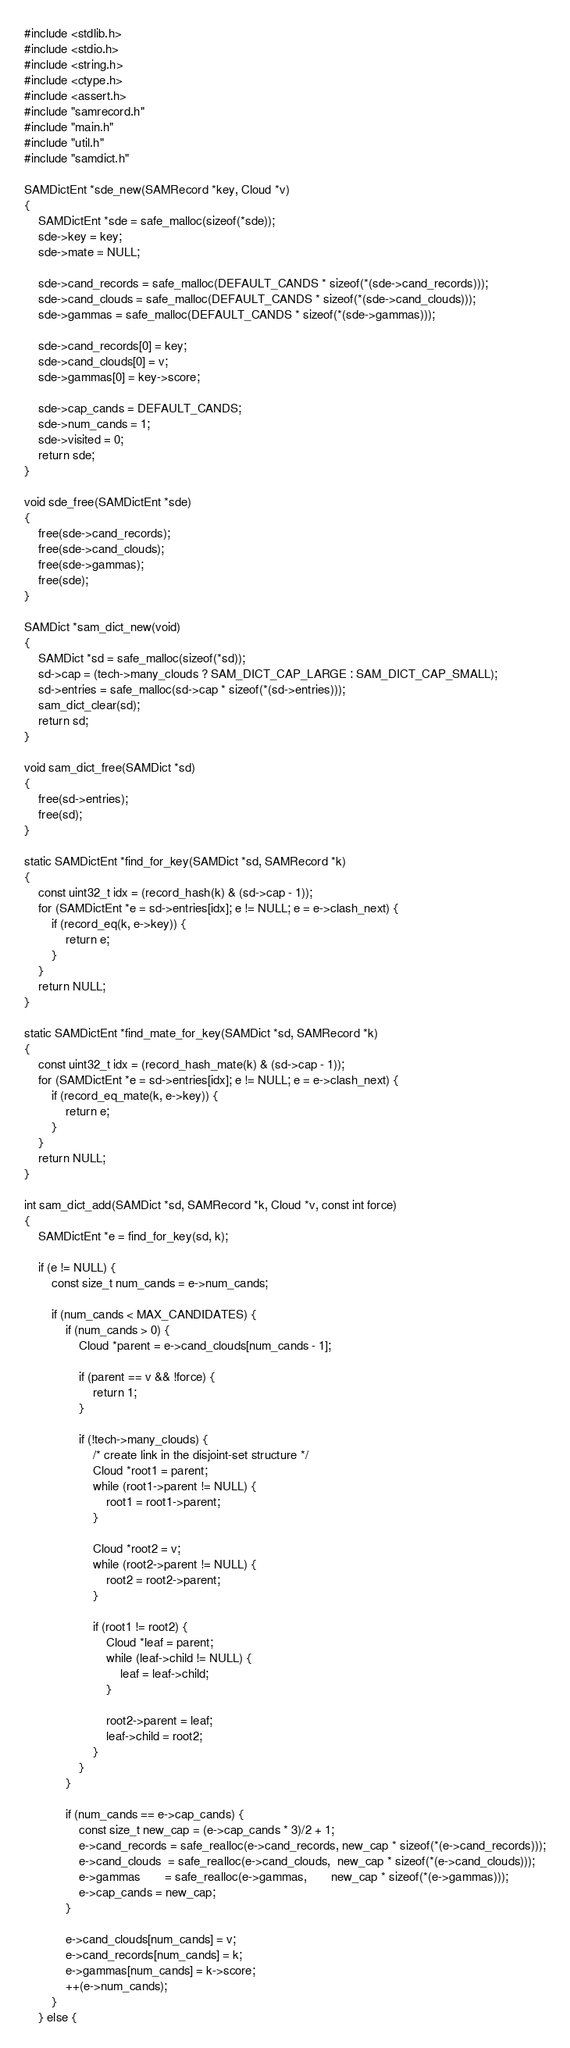<code> <loc_0><loc_0><loc_500><loc_500><_C_>#include <stdlib.h>
#include <stdio.h>
#include <string.h>
#include <ctype.h>
#include <assert.h>
#include "samrecord.h"
#include "main.h"
#include "util.h"
#include "samdict.h"

SAMDictEnt *sde_new(SAMRecord *key, Cloud *v)
{
	SAMDictEnt *sde = safe_malloc(sizeof(*sde));
	sde->key = key;
	sde->mate = NULL;

	sde->cand_records = safe_malloc(DEFAULT_CANDS * sizeof(*(sde->cand_records)));
	sde->cand_clouds = safe_malloc(DEFAULT_CANDS * sizeof(*(sde->cand_clouds)));
	sde->gammas = safe_malloc(DEFAULT_CANDS * sizeof(*(sde->gammas)));

	sde->cand_records[0] = key;
	sde->cand_clouds[0] = v;
	sde->gammas[0] = key->score;

	sde->cap_cands = DEFAULT_CANDS;
	sde->num_cands = 1;
	sde->visited = 0;
	return sde;
}

void sde_free(SAMDictEnt *sde)
{
	free(sde->cand_records);
	free(sde->cand_clouds);
	free(sde->gammas);
	free(sde);
}

SAMDict *sam_dict_new(void)
{
	SAMDict *sd = safe_malloc(sizeof(*sd));
	sd->cap = (tech->many_clouds ? SAM_DICT_CAP_LARGE : SAM_DICT_CAP_SMALL);
	sd->entries = safe_malloc(sd->cap * sizeof(*(sd->entries)));
	sam_dict_clear(sd);
	return sd;
}

void sam_dict_free(SAMDict *sd)
{
	free(sd->entries);
	free(sd);
}

static SAMDictEnt *find_for_key(SAMDict *sd, SAMRecord *k)
{
	const uint32_t idx = (record_hash(k) & (sd->cap - 1));
	for (SAMDictEnt *e = sd->entries[idx]; e != NULL; e = e->clash_next) {
		if (record_eq(k, e->key)) {
			return e;
		}
	}
	return NULL;
}

static SAMDictEnt *find_mate_for_key(SAMDict *sd, SAMRecord *k)
{
	const uint32_t idx = (record_hash_mate(k) & (sd->cap - 1));
	for (SAMDictEnt *e = sd->entries[idx]; e != NULL; e = e->clash_next) {
		if (record_eq_mate(k, e->key)) {
			return e;
		}
	}
	return NULL;
}

int sam_dict_add(SAMDict *sd, SAMRecord *k, Cloud *v, const int force)
{
	SAMDictEnt *e = find_for_key(sd, k);

	if (e != NULL) {
		const size_t num_cands = e->num_cands;

		if (num_cands < MAX_CANDIDATES) {
			if (num_cands > 0) {
				Cloud *parent = e->cand_clouds[num_cands - 1];

				if (parent == v && !force) {
					return 1;
				}

				if (!tech->many_clouds) {
					/* create link in the disjoint-set structure */
					Cloud *root1 = parent;
					while (root1->parent != NULL) {
						root1 = root1->parent;
					}

					Cloud *root2 = v;
					while (root2->parent != NULL) {
						root2 = root2->parent;
					}

					if (root1 != root2) {
						Cloud *leaf = parent;
						while (leaf->child != NULL) {
							leaf = leaf->child;
						}

						root2->parent = leaf;
						leaf->child = root2;
					}
				}
			}

			if (num_cands == e->cap_cands) {
				const size_t new_cap = (e->cap_cands * 3)/2 + 1;
				e->cand_records = safe_realloc(e->cand_records, new_cap * sizeof(*(e->cand_records)));
				e->cand_clouds  = safe_realloc(e->cand_clouds,  new_cap * sizeof(*(e->cand_clouds)));
				e->gammas       = safe_realloc(e->gammas,       new_cap * sizeof(*(e->gammas)));
				e->cap_cands = new_cap;
			}

			e->cand_clouds[num_cands] = v;
			e->cand_records[num_cands] = k;
			e->gammas[num_cands] = k->score;
			++(e->num_cands);
		}
	} else {</code> 